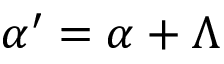<formula> <loc_0><loc_0><loc_500><loc_500>{ \alpha } ^ { \prime } = { \alpha } + { \Lambda }</formula> 